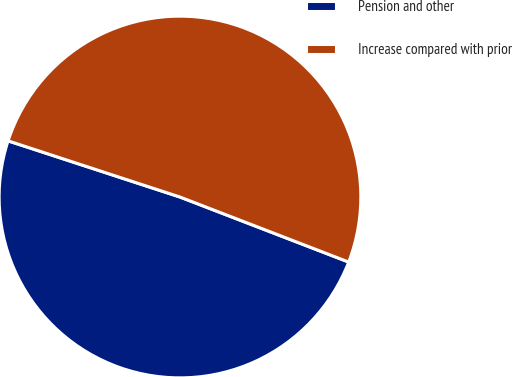Convert chart to OTSL. <chart><loc_0><loc_0><loc_500><loc_500><pie_chart><fcel>Pension and other<fcel>Increase compared with prior<nl><fcel>49.17%<fcel>50.83%<nl></chart> 